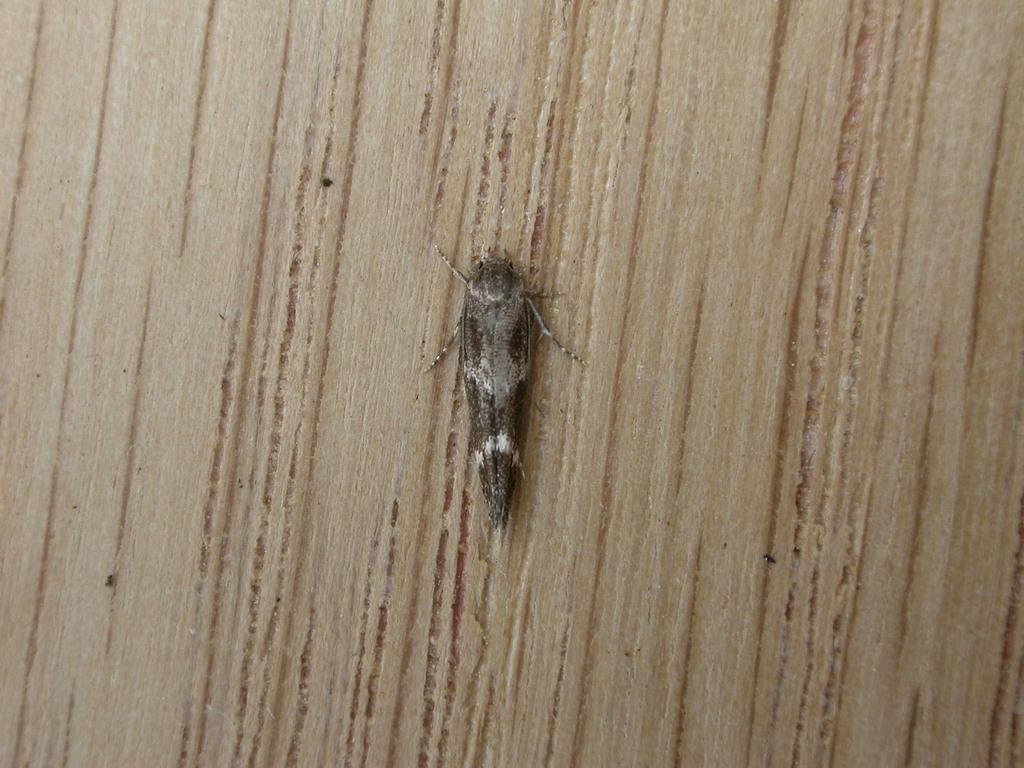What type of creature is present in the image? There is an insect in the image. What is the color of the surface where the insect is located? The insect is on a cream-colored surface. What is the color of the insect? The insect is gray in color. What is the name of the laborer in the image? There is no laborer present in the image; it features an insect on a cream-colored surface. Can you tell me the breed of the kitty in the image? There is no kitty present in the image; it features an insect on a cream-colored surface. 